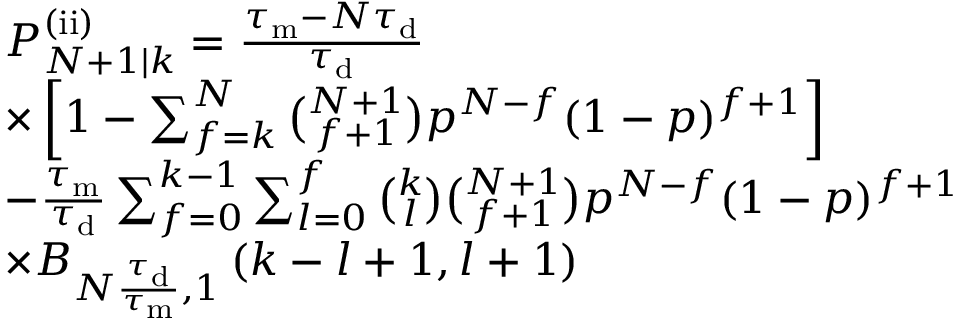Convert formula to latex. <formula><loc_0><loc_0><loc_500><loc_500>\begin{array} { r l } & { P _ { N + 1 | k } ^ { ( i i ) } = \frac { \tau _ { m } - N \tau _ { d } } { \tau _ { d } } } \\ & { \times \left [ 1 - \sum _ { f = k } ^ { N } \binom { N + 1 } { f + 1 } p ^ { N - f } ( 1 - p ) ^ { f + 1 } \right ] } \\ & { - \frac { \tau _ { m } } { \tau _ { d } } \sum _ { f = 0 } ^ { k - 1 } \sum _ { l = 0 } ^ { f } \binom { k } { l } \binom { N + 1 } { f + 1 } p ^ { N - f } ( 1 - p ) ^ { f + 1 } } \\ & { \times B _ { N \frac { \tau _ { d } } { \tau _ { m } } , 1 } \left ( k - l + 1 , l + 1 \right ) } \end{array}</formula> 